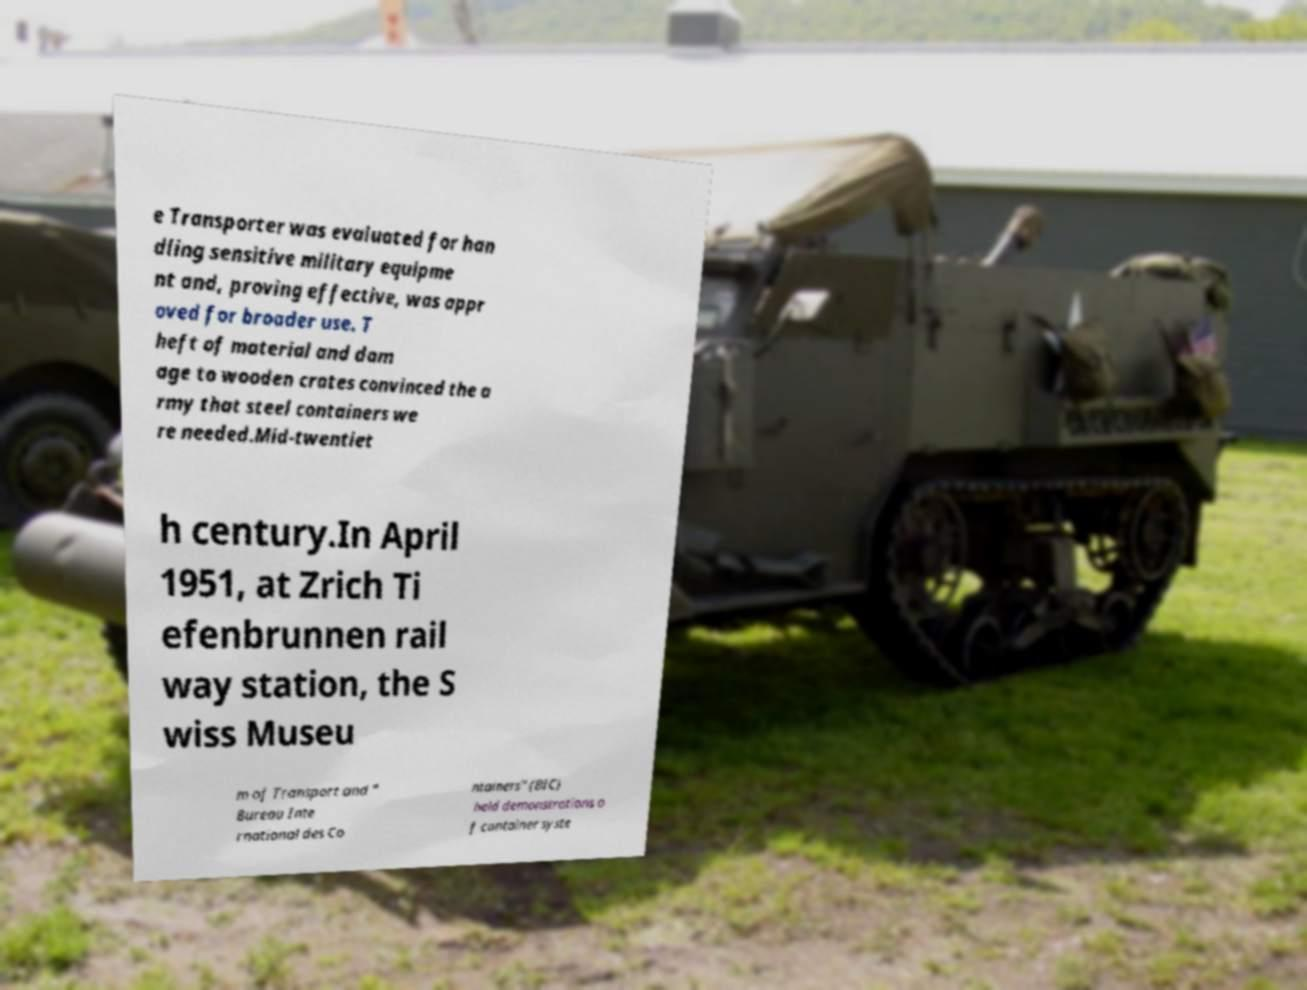Please read and relay the text visible in this image. What does it say? e Transporter was evaluated for han dling sensitive military equipme nt and, proving effective, was appr oved for broader use. T heft of material and dam age to wooden crates convinced the a rmy that steel containers we re needed.Mid-twentiet h century.In April 1951, at Zrich Ti efenbrunnen rail way station, the S wiss Museu m of Transport and " Bureau Inte rnational des Co ntainers" (BIC) held demonstrations o f container syste 